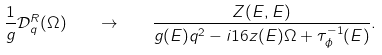Convert formula to latex. <formula><loc_0><loc_0><loc_500><loc_500>\frac { 1 } { g } \mathcal { D } ^ { R } _ { q } ( \Omega ) \quad \to \quad \frac { Z ( E , E ) } { g ( E ) q ^ { 2 } - i 1 6 z ( E ) \Omega + \tau _ { \phi } ^ { - 1 } ( E ) } .</formula> 